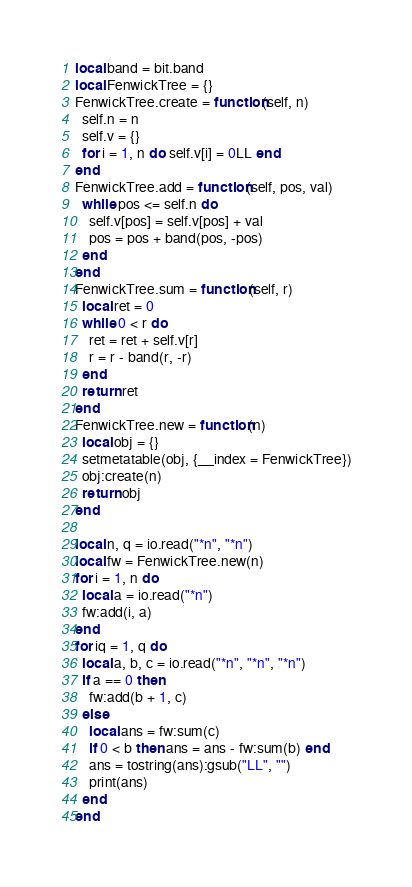<code> <loc_0><loc_0><loc_500><loc_500><_Lua_>local band = bit.band
local FenwickTree = {}
FenwickTree.create = function(self, n)
  self.n = n
  self.v = {}
  for i = 1, n do self.v[i] = 0LL end
end
FenwickTree.add = function(self, pos, val)
  while pos <= self.n do
    self.v[pos] = self.v[pos] + val
    pos = pos + band(pos, -pos)
  end
end
FenwickTree.sum = function(self, r)
  local ret = 0
  while 0 < r do
    ret = ret + self.v[r]
    r = r - band(r, -r)
  end
  return ret
end
FenwickTree.new = function(n)
  local obj = {}
  setmetatable(obj, {__index = FenwickTree})
  obj:create(n)
  return obj
end

local n, q = io.read("*n", "*n")
local fw = FenwickTree.new(n)
for i = 1, n do
  local a = io.read("*n")
  fw:add(i, a)
end
for iq = 1, q do
  local a, b, c = io.read("*n", "*n", "*n")
  if a == 0 then
    fw:add(b + 1, c)
  else
    local ans = fw:sum(c)
    if 0 < b then ans = ans - fw:sum(b) end
    ans = tostring(ans):gsub("LL", "")
    print(ans)
  end
end
</code> 